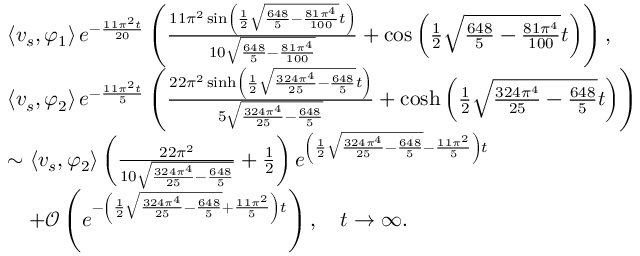Convert formula to latex. <formula><loc_0><loc_0><loc_500><loc_500>\begin{array} { r l } & { \left \langle v _ { s } , \varphi _ { 1 } \right \rangle e ^ { - \frac { 1 1 \pi ^ { 2 } t } { 2 0 } } \left ( \frac { 1 1 \pi ^ { 2 } \sin \left ( \frac { 1 } { 2 } \sqrt { \frac { 6 4 8 } { 5 } - \frac { 8 1 \pi ^ { 4 } } { 1 0 0 } } t \right ) } { 1 0 \sqrt { \frac { 6 4 8 } { 5 } - \frac { 8 1 \pi ^ { 4 } } { 1 0 0 } } } + \cos \left ( \frac { 1 } { 2 } \sqrt { \frac { 6 4 8 } { 5 } - \frac { 8 1 \pi ^ { 4 } } { 1 0 0 } } t \right ) \right ) , } \\ & { \left \langle v _ { s } , \varphi _ { 2 } \right \rangle e ^ { - \frac { 1 1 \pi ^ { 2 } t } { 5 } } \left ( \frac { 2 2 \pi ^ { 2 } \sinh \left ( \frac { 1 } { 2 } \sqrt { \frac { 3 2 4 \pi ^ { 4 } } { 2 5 } - \frac { 6 4 8 } { 5 } } t \right ) } { 5 \sqrt { \frac { 3 2 4 \pi ^ { 4 } } { 2 5 } - \frac { 6 4 8 } { 5 } } } + \cosh \left ( \frac { 1 } { 2 } \sqrt { \frac { 3 2 4 \pi ^ { 4 } } { 2 5 } - \frac { 6 4 8 } { 5 } } t \right ) \right ) } \\ & { \sim \left \langle v _ { s } , \varphi _ { 2 } \right \rangle \left ( \frac { 2 2 \pi ^ { 2 } } { 1 0 \sqrt { \frac { 3 2 4 \pi ^ { 4 } } { 2 5 } - \frac { 6 4 8 } { 5 } } } + \frac { 1 } { 2 } \right ) e ^ { \left ( \frac { 1 } { 2 } \sqrt { \frac { 3 2 4 \pi ^ { 4 } } { 2 5 } - \frac { 6 4 8 } { 5 } } - \frac { 1 1 \pi ^ { 2 } } { 5 } \right ) t } } \\ & { \quad + \mathcal { O } \left ( e ^ { - \left ( \frac { 1 } { 2 } \sqrt { \frac { 3 2 4 \pi ^ { 4 } } { 2 5 } - \frac { 6 4 8 } { 5 } } + \frac { 1 1 \pi ^ { 2 } } { 5 } \right ) t } \right ) , \quad t \rightarrow \infty . } \end{array}</formula> 